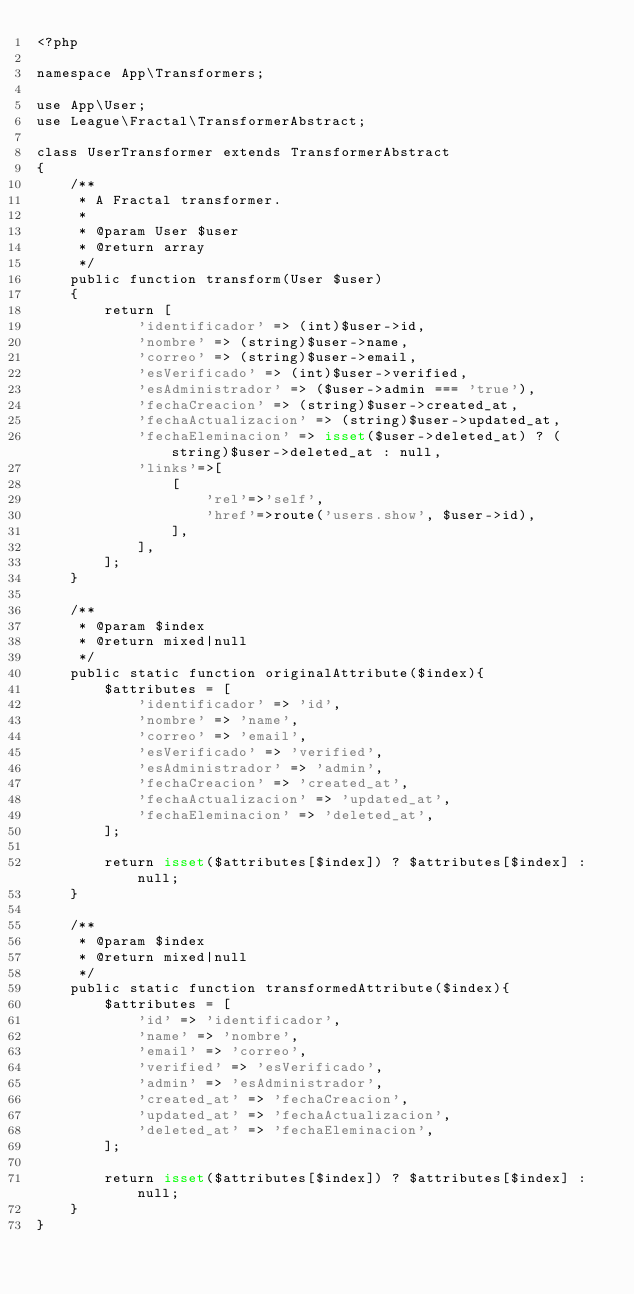<code> <loc_0><loc_0><loc_500><loc_500><_PHP_><?php

namespace App\Transformers;

use App\User;
use League\Fractal\TransformerAbstract;

class UserTransformer extends TransformerAbstract
{
    /**
     * A Fractal transformer.
     *
     * @param User $user
     * @return array
     */
    public function transform(User $user)
    {
        return [
            'identificador' => (int)$user->id,
            'nombre' => (string)$user->name,
            'correo' => (string)$user->email,
            'esVerificado' => (int)$user->verified,
            'esAdministrador' => ($user->admin === 'true'),
            'fechaCreacion' => (string)$user->created_at,
            'fechaActualizacion' => (string)$user->updated_at,
            'fechaEleminacion' => isset($user->deleted_at) ? (string)$user->deleted_at : null,
            'links'=>[
                [
                    'rel'=>'self',
                    'href'=>route('users.show', $user->id),
                ],
            ],
        ];
    }

    /**
     * @param $index
     * @return mixed|null
     */
    public static function originalAttribute($index){
        $attributes = [
            'identificador' => 'id',
            'nombre' => 'name',
            'correo' => 'email',
            'esVerificado' => 'verified',
            'esAdministrador' => 'admin',
            'fechaCreacion' => 'created_at',
            'fechaActualizacion' => 'updated_at',
            'fechaEleminacion' => 'deleted_at',
        ];

        return isset($attributes[$index]) ? $attributes[$index] : null;
    }

    /**
     * @param $index
     * @return mixed|null
     */
    public static function transformedAttribute($index){
        $attributes = [
            'id' => 'identificador',
            'name' => 'nombre',
            'email' => 'correo',
            'verified' => 'esVerificado',
            'admin' => 'esAdministrador',
            'created_at' => 'fechaCreacion',
            'updated_at' => 'fechaActualizacion',
            'deleted_at' => 'fechaEleminacion',
        ];

        return isset($attributes[$index]) ? $attributes[$index] : null;
    }
}
</code> 